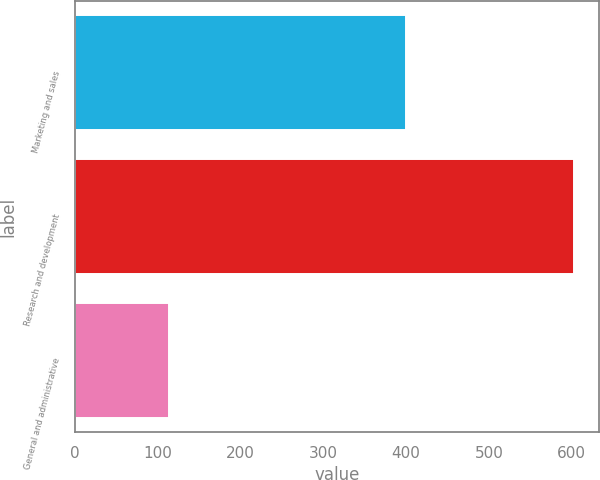Convert chart to OTSL. <chart><loc_0><loc_0><loc_500><loc_500><bar_chart><fcel>Marketing and sales<fcel>Research and development<fcel>General and administrative<nl><fcel>399.7<fcel>603<fcel>113.6<nl></chart> 